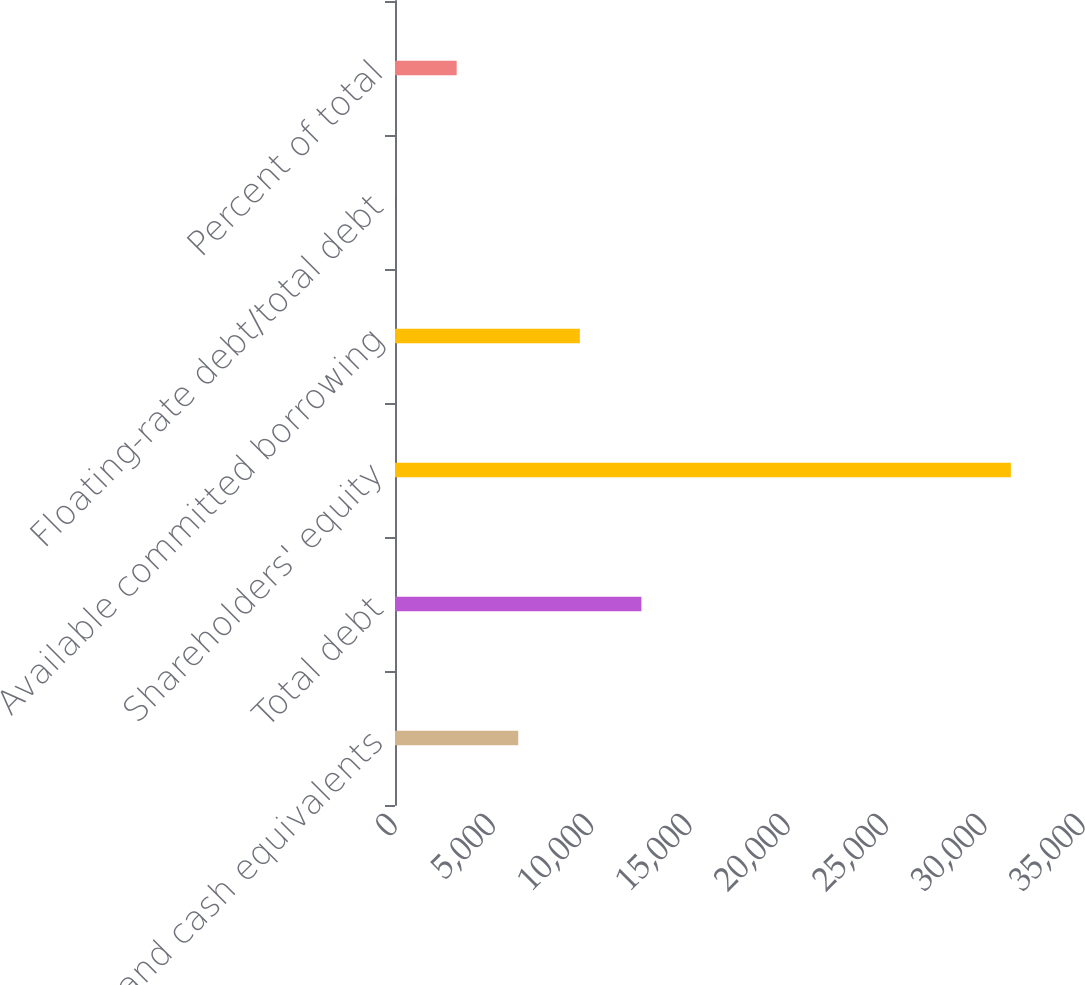Convert chart to OTSL. <chart><loc_0><loc_0><loc_500><loc_500><bar_chart><fcel>Cash and cash equivalents<fcel>Total debt<fcel>Shareholders' equity<fcel>Available committed borrowing<fcel>Floating-rate debt/total debt<fcel>Percent of total<nl><fcel>6270.2<fcel>12535.4<fcel>31331<fcel>9402.8<fcel>5<fcel>3137.6<nl></chart> 